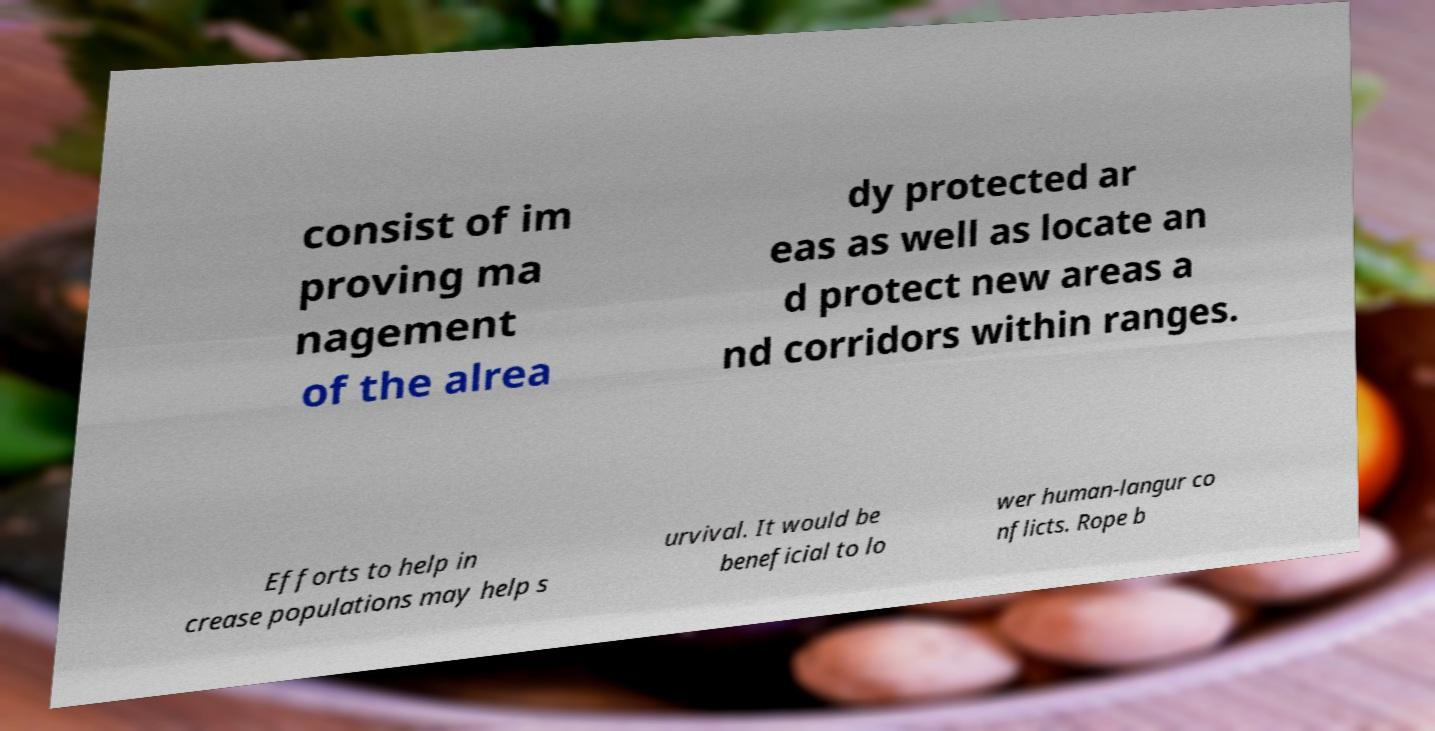Can you accurately transcribe the text from the provided image for me? consist of im proving ma nagement of the alrea dy protected ar eas as well as locate an d protect new areas a nd corridors within ranges. Efforts to help in crease populations may help s urvival. It would be beneficial to lo wer human-langur co nflicts. Rope b 